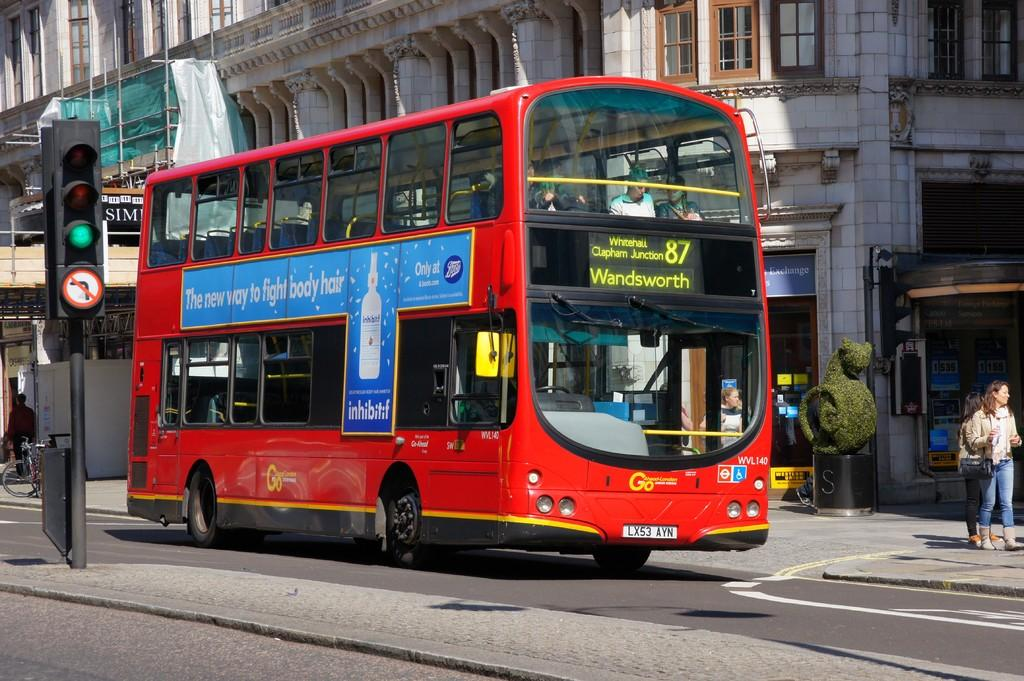Provide a one-sentence caption for the provided image. A red bus number 87 is heading to Wandsworth. 